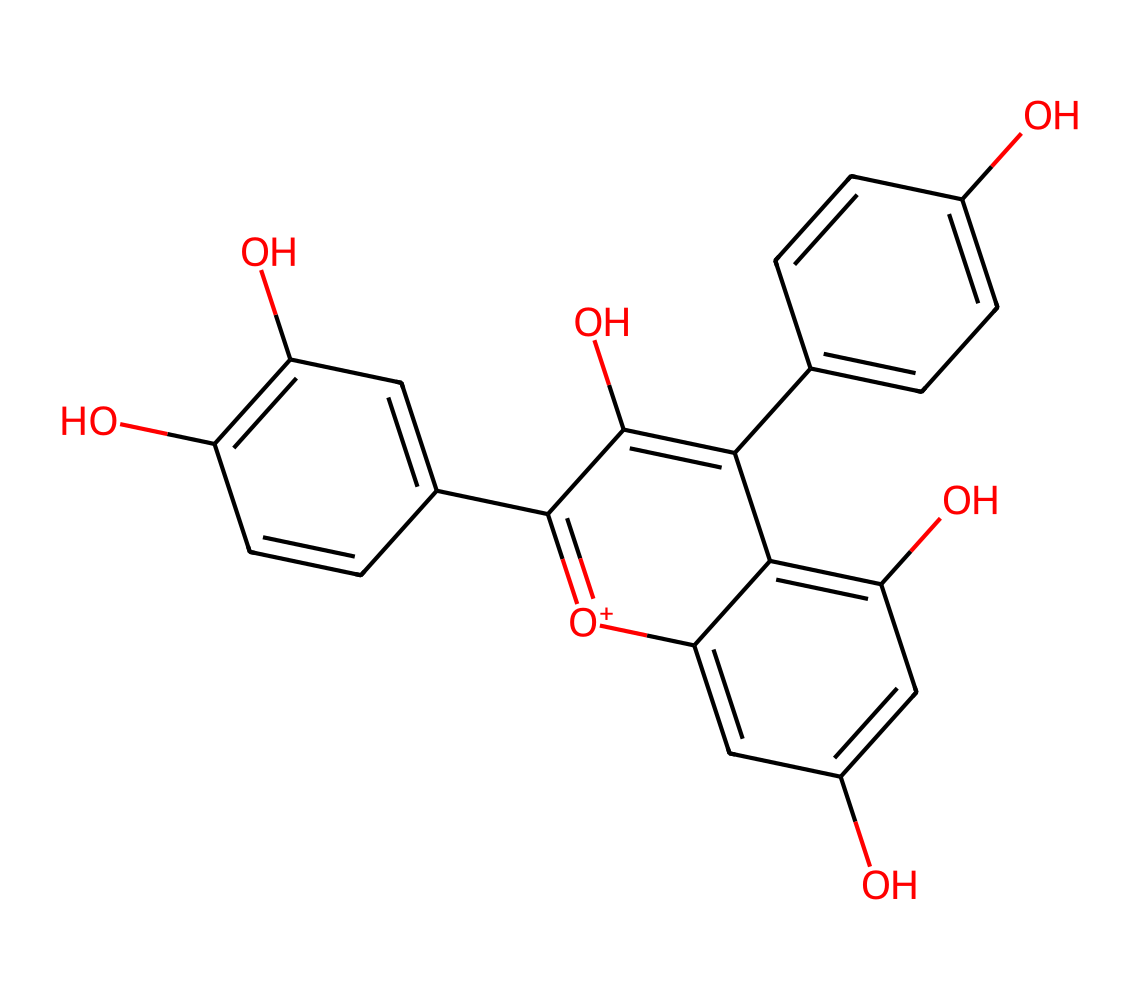How many carbon atoms are in this chemical? By analyzing the SMILES representation, each carbon atom is represented by a 'C' character. Counting all instances of 'C' in the structure gives a total count of carbon atoms.
Answer: 15 What is the molecular formula for this chemical? To determine the molecular formula, count the number of each type of atom represented in the SMILES. After counting, you find there are 15 carbon, 11 hydrogen, and 6 oxygen atoms, leading to the formula C15H11O6.
Answer: C15H11O6 What type of bonds are predominantly present in this chemical? By inspecting the structure derived from the SMILES, we note that it consists primarily of aromatic rings and hydroxyl (-OH) groups which suggest many single and double carbon-carbon bonds within those rings. This indicates predominantly covalent bonds.
Answer: covalent Which functional groups are found in this molecule? Recognizing functional groups entails identifying characteristic groups like -OH (hydroxyl). The structure has several -OH groups evident from their presence, making them significant functional groups.
Answer: hydroxyl What role do the hydroxyl groups play in this chemical? Hydroxyl groups are known to enhance the solubility of the molecule in water and contribute to its photoreactive properties by interacting with light, which is essential for the vibrant colors produced by anthocyanins.
Answer: photoreactivity Is this chemical likely to exhibit strong color? Yes, based on the presence of many conjugated systems (multiple alternating double bonds) found in anthocyanins, which allow for strong light absorption, resulting in vivid colors.
Answer: yes What type of photoreactive property is associated with this type of compound? Anthocyanins typically exhibit a property called "photoisomerization," where the compounds change structure under light, affecting their color and stability, essential in plants for attracting pollinators.
Answer: photoisomerization 